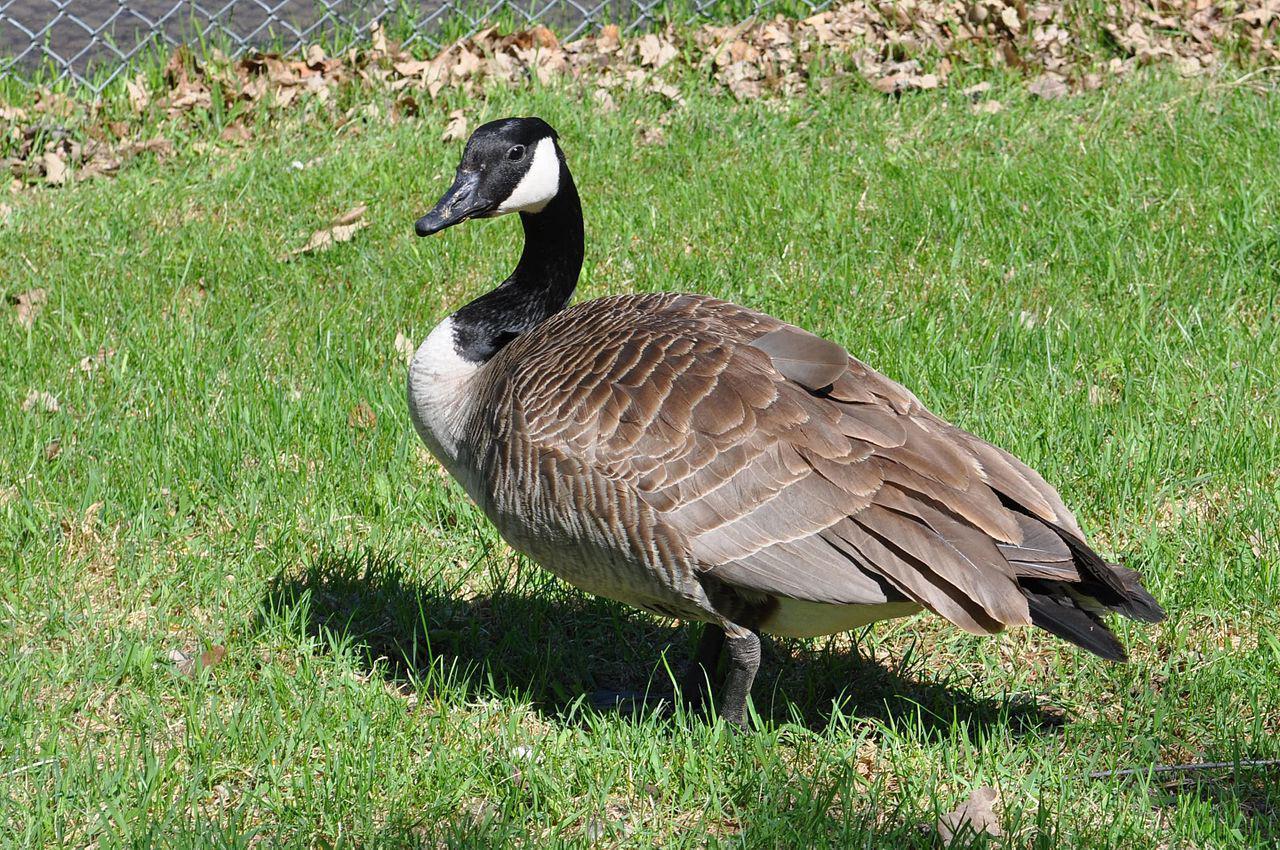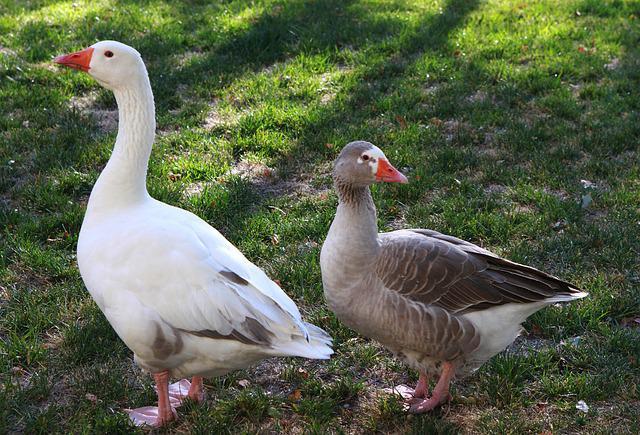The first image is the image on the left, the second image is the image on the right. Assess this claim about the two images: "Only geese with black and white faces are shown.". Correct or not? Answer yes or no. No. 